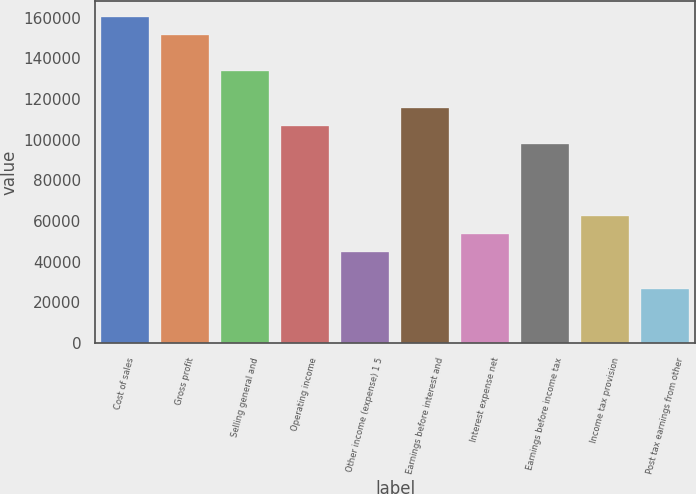Convert chart to OTSL. <chart><loc_0><loc_0><loc_500><loc_500><bar_chart><fcel>Cost of sales<fcel>Gross profit<fcel>Selling general and<fcel>Operating income<fcel>Other income (expense) 1 5<fcel>Earnings before interest and<fcel>Interest expense net<fcel>Earnings before income tax<fcel>Income tax provision<fcel>Post tax earnings from other<nl><fcel>160292<fcel>151387<fcel>133577<fcel>106862<fcel>44526.8<fcel>115767<fcel>53431.8<fcel>97957.1<fcel>62336.9<fcel>26716.7<nl></chart> 